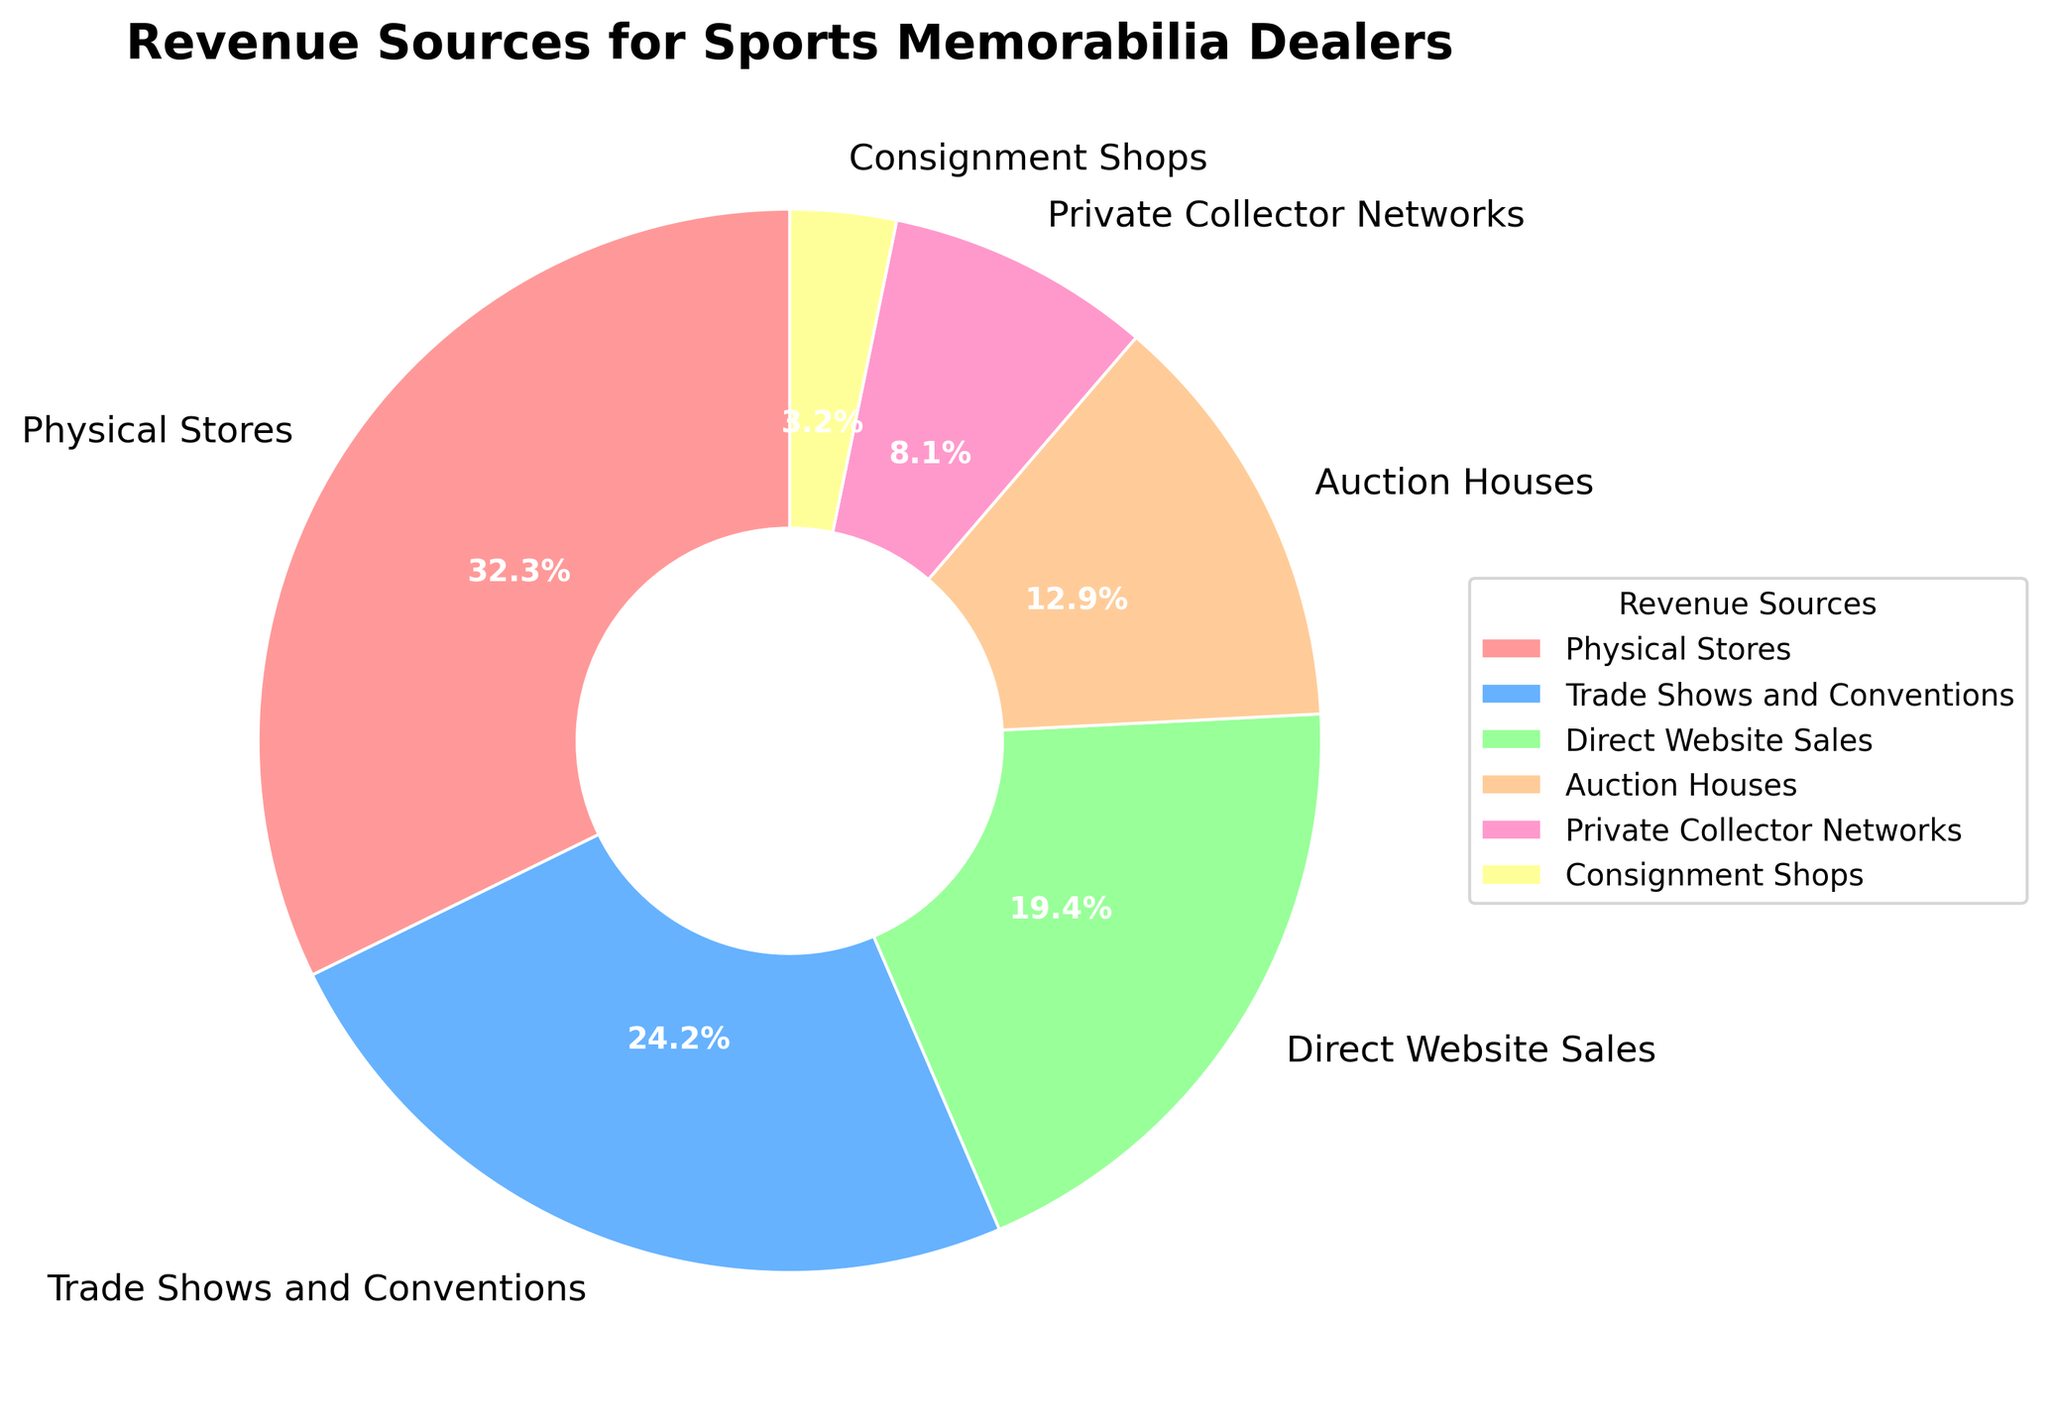What is the largest revenue source for sports memorabilia dealers? The largest revenue source can be identified by finding the section of the pie chart with the largest percentage. Physical Stores are largest with 20%.
Answer: Physical Stores Which two revenue sources have the closest percentages? Compare the percentages of all sources to find the two that are numerically closest to each other. Direct Website Sales (12%) and Auction Houses (8%) differ by 4 percentage points.
Answer: Direct Website Sales and Auction Houses What is the combined percentage for Trade Shows and Conventions and Auction Houses? Add the percentages of Trade Shows and Conventions (15%) and Auction Houses (8%). 15 + 8 = 23.
Answer: 23% How many revenue sources have a percentage contribution greater than 10%? Identify the sections of the pie chart with percentages greater than 10%. Physical Stores, Trade Shows and Conventions, and Direct Website Sales are greater than 10%.
Answer: 3 Which revenue source is represented by the green color? Determine the section of the pie chart that is colored green. Direct Website Sales are represented by green.
Answer: Direct Website Sales What percentage of revenue comes from sources other than Physical Stores and Trade Shows and Conventions? Subtract the combined percentages of Physical Stores and Trade Shows and Conventions (20% + 15%) from 100%. 100 - 35 = 65.
Answer: 65% Is Private Collector Networks' contribution more or less than Consignment Shops? Compare the percentages of Private Collector Networks (5%) and Consignment Shops (2%). Private Collector Networks is more.
Answer: More What is the difference in percentage points between Physical Stores and Direct Website Sales? Subtract the percentage of Direct Website Sales from the percentage of Physical Stores. 20 - 12 = 8.
Answer: 8% Which revenue source lies between Trade Shows and Conventions and Consignment Shops in the pie chart? Identify the revenue source placed between Trade Shows and Conventions and Consignment Shops based on the pie chart. Direct Website Sales lies between them.
Answer: Direct Website Sales What percentage do all revenue sources that contribute less than 10% add up to? Add the percentages of all sources contributing less than 10%. Auction Houses (8%) + Private Collector Networks (5%) + Consignment Shops (2%) = 15.
Answer: 15% 